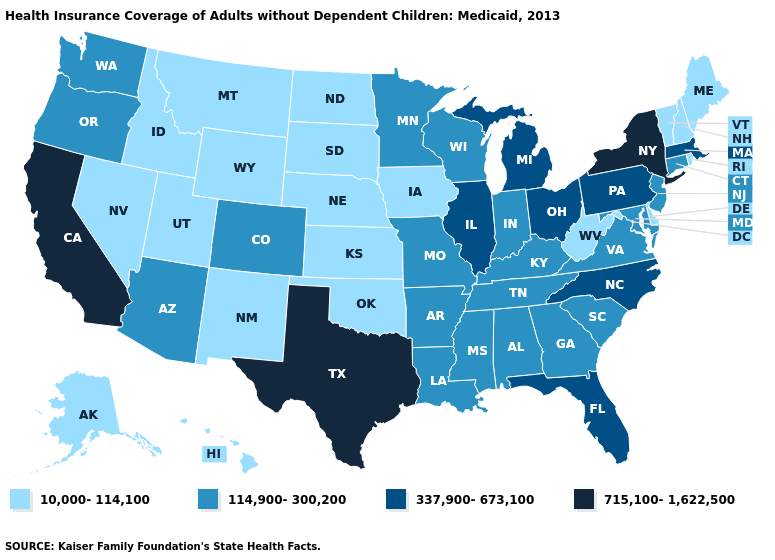What is the value of Oregon?
Answer briefly. 114,900-300,200. What is the value of South Carolina?
Keep it brief. 114,900-300,200. Is the legend a continuous bar?
Write a very short answer. No. Among the states that border Illinois , does Iowa have the highest value?
Write a very short answer. No. Does Illinois have a lower value than New York?
Concise answer only. Yes. What is the value of Idaho?
Be succinct. 10,000-114,100. How many symbols are there in the legend?
Concise answer only. 4. Which states have the lowest value in the USA?
Quick response, please. Alaska, Delaware, Hawaii, Idaho, Iowa, Kansas, Maine, Montana, Nebraska, Nevada, New Hampshire, New Mexico, North Dakota, Oklahoma, Rhode Island, South Dakota, Utah, Vermont, West Virginia, Wyoming. Which states have the highest value in the USA?
Concise answer only. California, New York, Texas. Among the states that border Arkansas , which have the highest value?
Keep it brief. Texas. What is the value of Oklahoma?
Quick response, please. 10,000-114,100. Among the states that border West Virginia , which have the highest value?
Concise answer only. Ohio, Pennsylvania. What is the highest value in the South ?
Keep it brief. 715,100-1,622,500. What is the value of Kentucky?
Give a very brief answer. 114,900-300,200. Among the states that border Pennsylvania , does West Virginia have the highest value?
Keep it brief. No. 